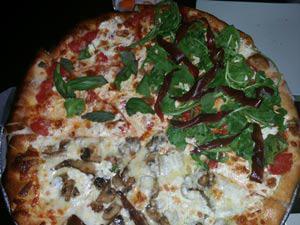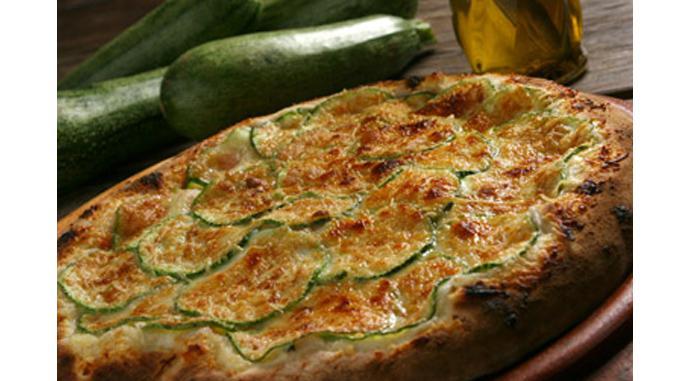The first image is the image on the left, the second image is the image on the right. Evaluate the accuracy of this statement regarding the images: "The left and right image contains the same number of circle shaped pizzas.". Is it true? Answer yes or no. Yes. The first image is the image on the left, the second image is the image on the right. Assess this claim about the two images: "At least one pizza has a slice cut out of it.". Correct or not? Answer yes or no. No. 